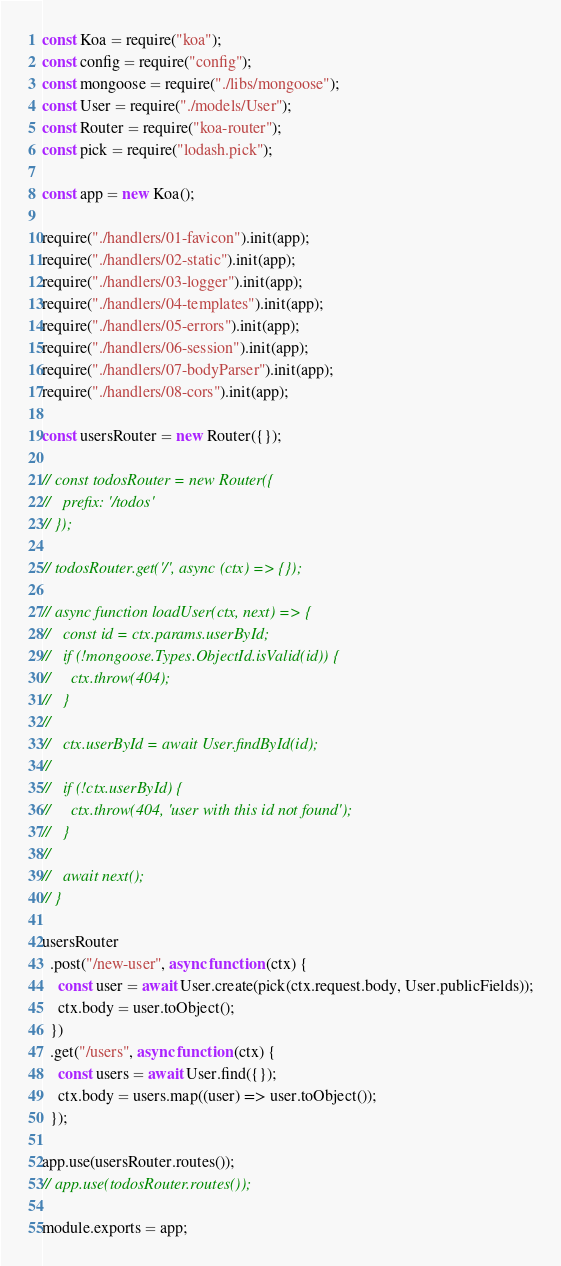<code> <loc_0><loc_0><loc_500><loc_500><_JavaScript_>const Koa = require("koa");
const config = require("config");
const mongoose = require("./libs/mongoose");
const User = require("./models/User");
const Router = require("koa-router");
const pick = require("lodash.pick");

const app = new Koa();

require("./handlers/01-favicon").init(app);
require("./handlers/02-static").init(app);
require("./handlers/03-logger").init(app);
require("./handlers/04-templates").init(app);
require("./handlers/05-errors").init(app);
require("./handlers/06-session").init(app);
require("./handlers/07-bodyParser").init(app);
require("./handlers/08-cors").init(app);

const usersRouter = new Router({});

// const todosRouter = new Router({
//   prefix: '/todos'
// });

// todosRouter.get('/', async (ctx) => {});

// async function loadUser(ctx, next) => {
//   const id = ctx.params.userById;
//   if (!mongoose.Types.ObjectId.isValid(id)) {
//     ctx.throw(404);
//   }
//
//   ctx.userById = await User.findById(id);
//
//   if (!ctx.userById) {
//     ctx.throw(404, 'user with this id not found');
//   }
//
//   await next();
// }

usersRouter
  .post("/new-user", async function (ctx) {
    const user = await User.create(pick(ctx.request.body, User.publicFields));
    ctx.body = user.toObject();
  })
  .get("/users", async function (ctx) {
    const users = await User.find({});
    ctx.body = users.map((user) => user.toObject());
  });

app.use(usersRouter.routes());
// app.use(todosRouter.routes());

module.exports = app;
</code> 